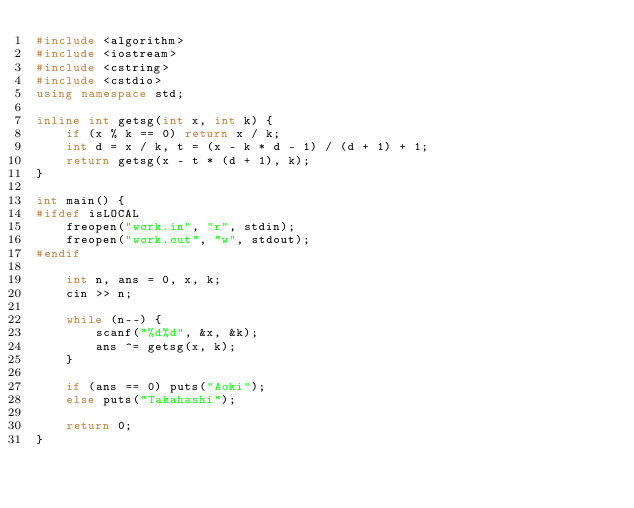<code> <loc_0><loc_0><loc_500><loc_500><_C++_>#include <algorithm>
#include <iostream>
#include <cstring>
#include <cstdio>
using namespace std;

inline int getsg(int x, int k) {
    if (x % k == 0) return x / k;
    int d = x / k, t = (x - k * d - 1) / (d + 1) + 1;
    return getsg(x - t * (d + 1), k);
}

int main() {
#ifdef isLOCAL
    freopen("work.in", "r", stdin);
    freopen("work.out", "w", stdout);
#endif

    int n, ans = 0, x, k;
    cin >> n;

    while (n--) {
        scanf("%d%d", &x, &k);
        ans ^= getsg(x, k);
    }

    if (ans == 0) puts("Aoki");
    else puts("Takahashi");
    
    return 0;
}
</code> 